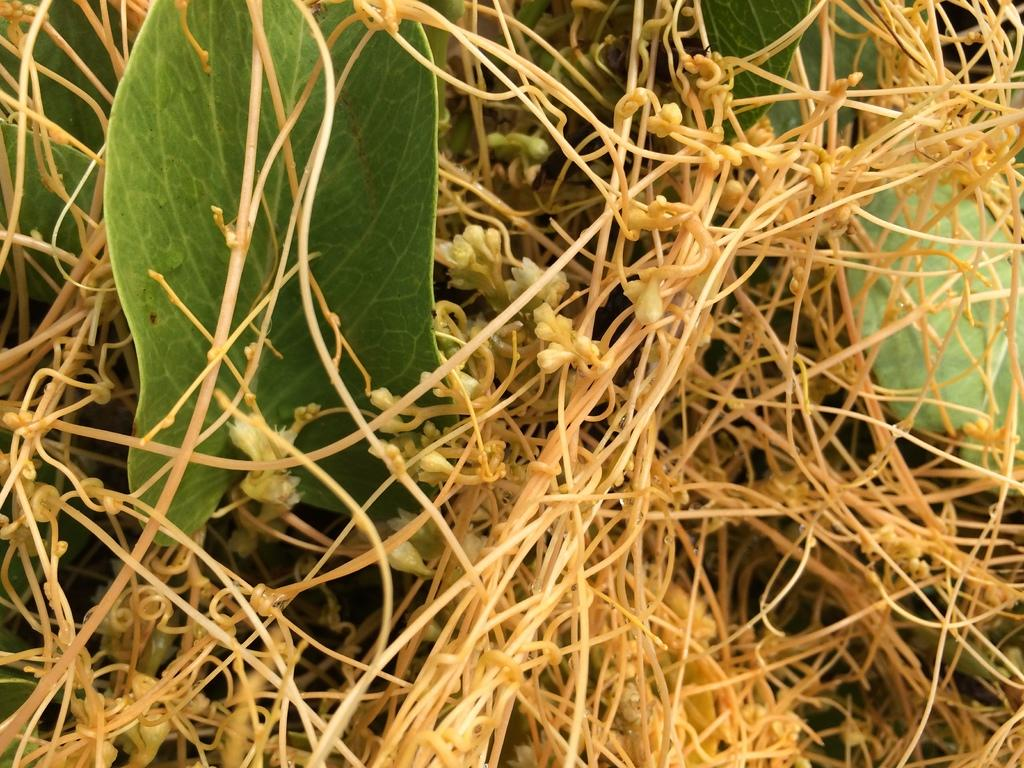What type of plant parts can be seen in the image? There are stems and leaves in the image. What do the stems and leaves belong to? The stems and leaves belong to a plant. Can you tell me how many giraffes are visible in the image? There are no giraffes present in the image; it features stems and leaves belonging to a plant. What type of memory is being used by the plant in the image? Plants do not have memories, so this question cannot be answered based on the image. 